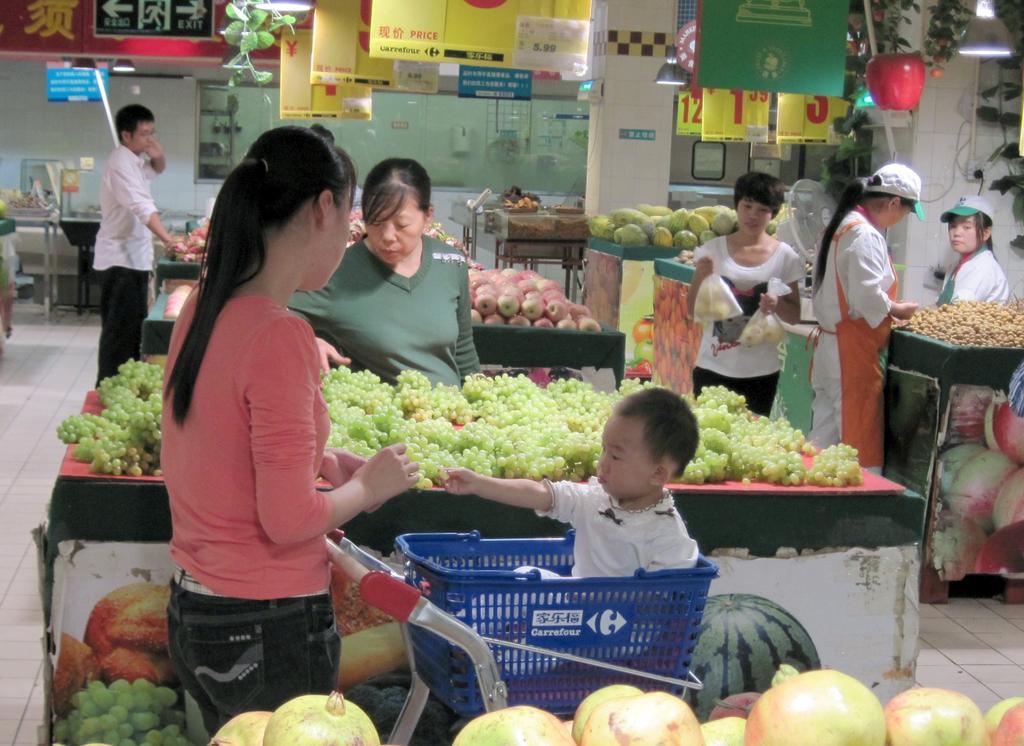Please provide a concise description of this image. In this image I can see it looks like a store, a woman is there, she wore t-shirt, trouser. In the middle there are grapes. At the bottom there are pomegranates. On the right side there are storekeepers, at the top there are boards with the numbers. 